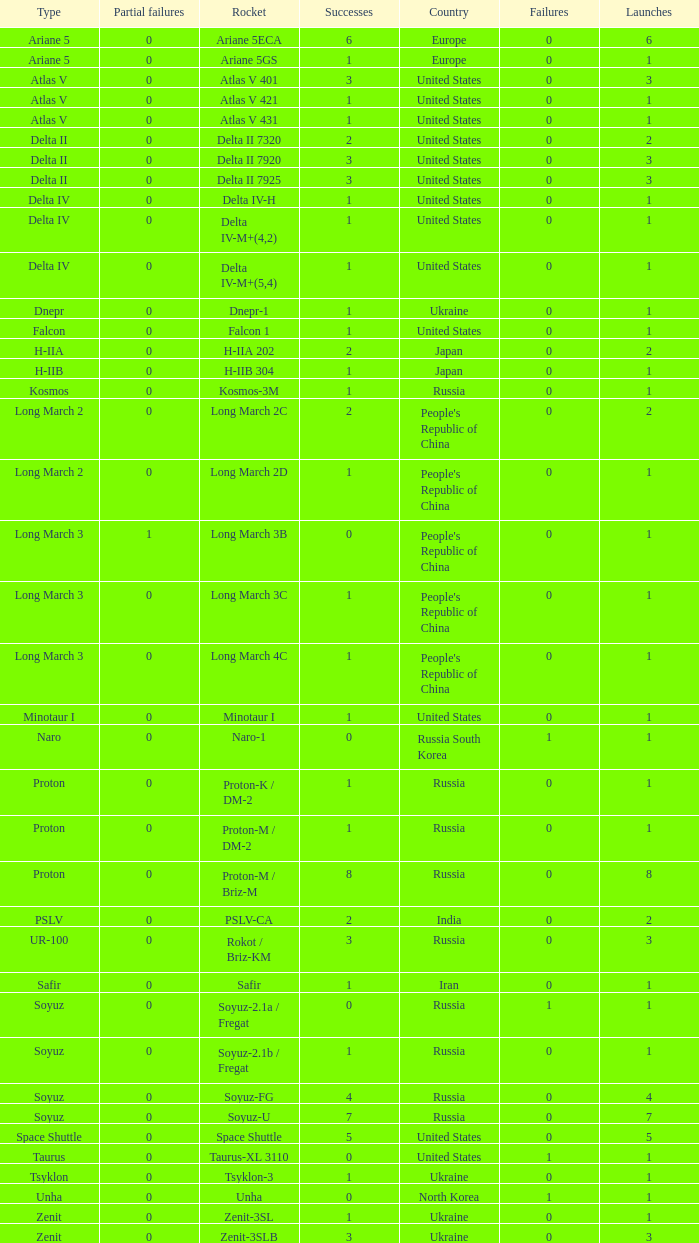What's the total failures among rockets that had more than 3 successes, type ariane 5 and more than 0 partial failures? 0.0. 